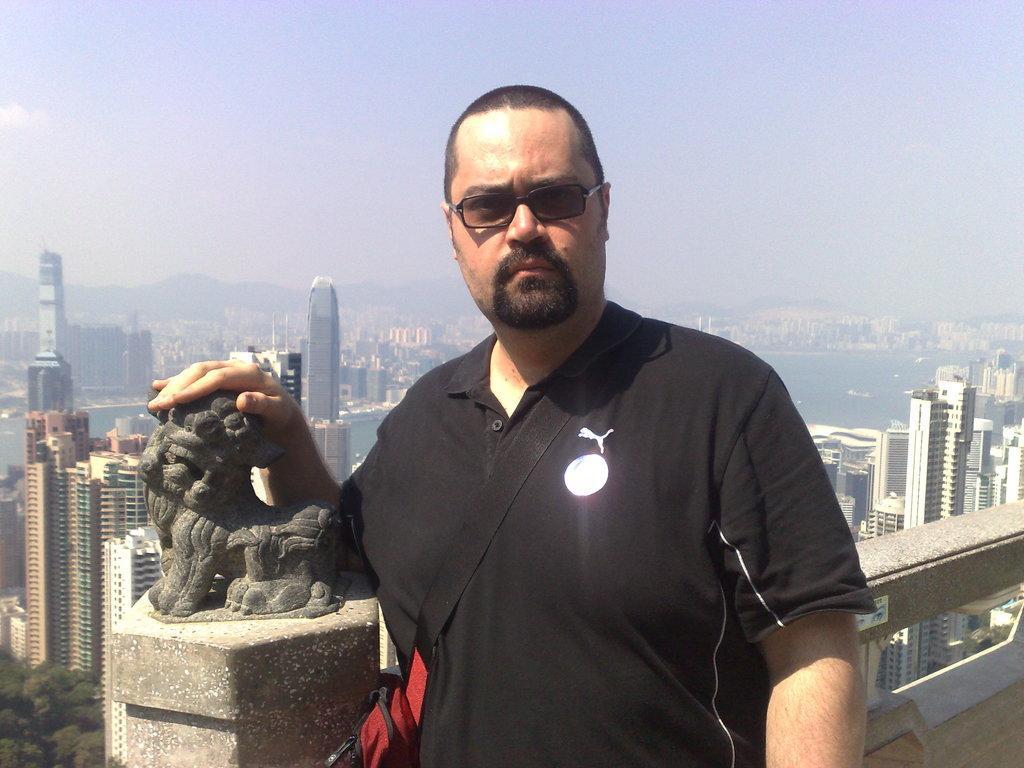Could you give a brief overview of what you see in this image? In this picture there is a man wearing black color t-shirt is standing in the front and giving a pose. Behind there are many skyscrapers and mountain in the background. 